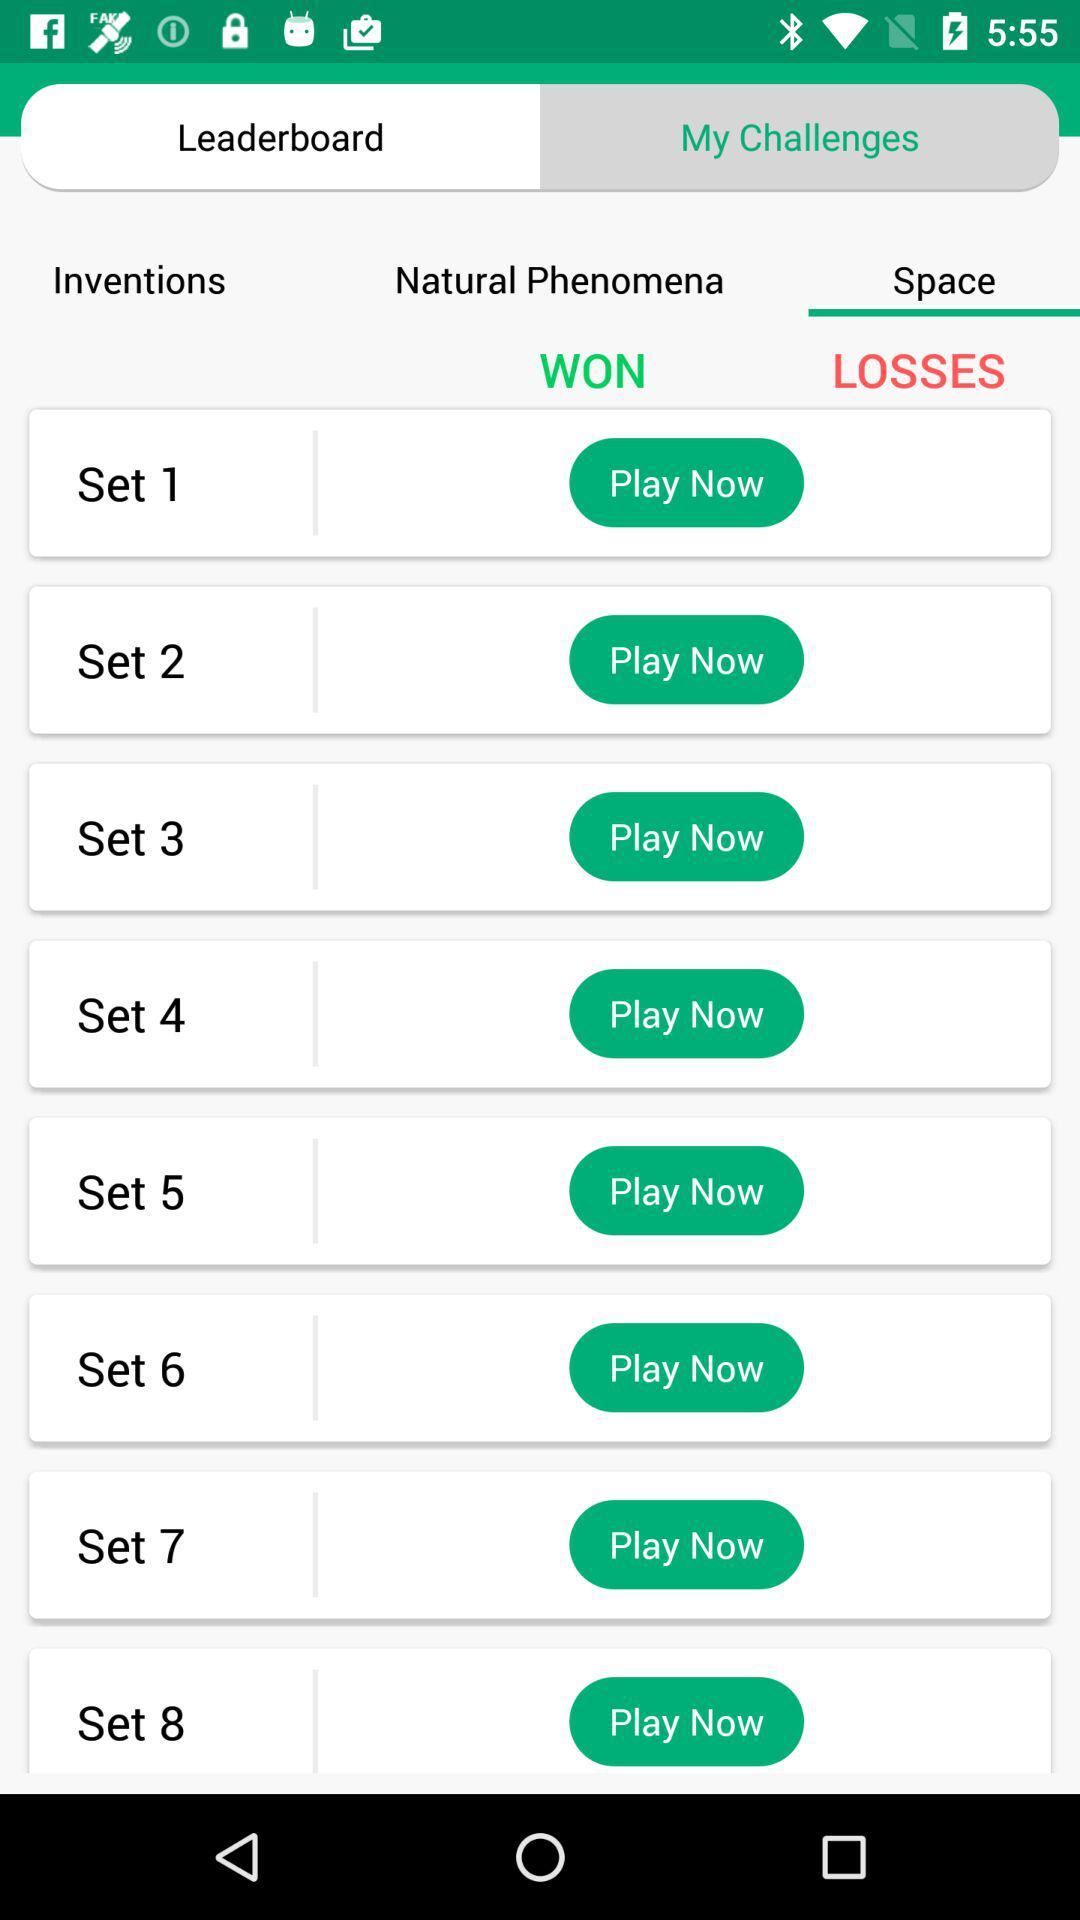How many sets are there in total?
Answer the question using a single word or phrase. 8 